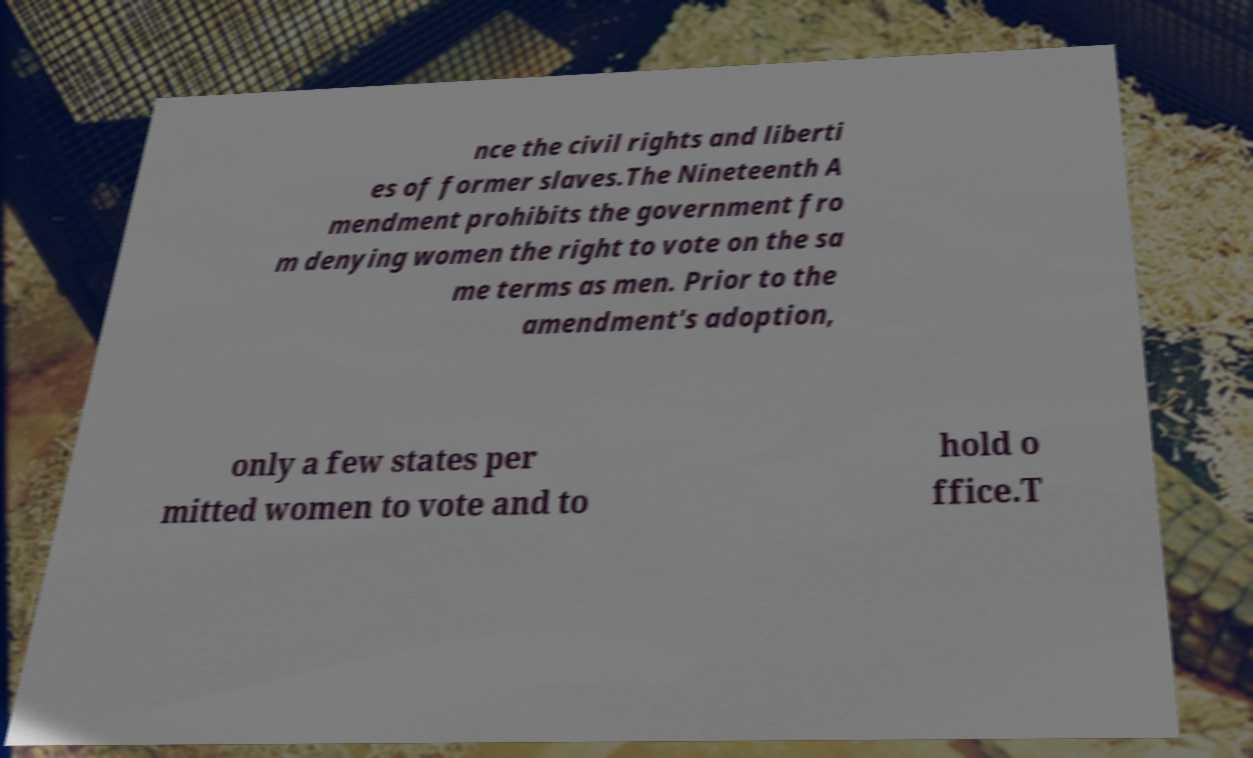Could you extract and type out the text from this image? nce the civil rights and liberti es of former slaves.The Nineteenth A mendment prohibits the government fro m denying women the right to vote on the sa me terms as men. Prior to the amendment's adoption, only a few states per mitted women to vote and to hold o ffice.T 